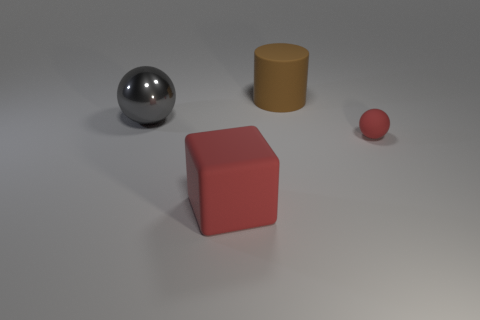Is there any other thing that is the same shape as the large brown object?
Offer a very short reply. No. What color is the matte object that is the same shape as the large gray shiny thing?
Ensure brevity in your answer.  Red. Is the shape of the tiny rubber object the same as the gray thing?
Provide a succinct answer. Yes. How many cylinders are red things or gray metallic objects?
Your answer should be very brief. 0. There is a large thing that is made of the same material as the big red cube; what is its color?
Your answer should be compact. Brown. Does the object that is in front of the rubber ball have the same size as the big gray object?
Your answer should be very brief. Yes. Do the large ball and the big object that is in front of the large gray sphere have the same material?
Offer a terse response. No. There is a rubber thing that is on the left side of the large brown rubber thing; what is its color?
Give a very brief answer. Red. There is a thing that is to the right of the brown rubber cylinder; is there a object that is to the right of it?
Offer a terse response. No. There is a large thing that is in front of the shiny sphere; is its color the same as the sphere that is in front of the big ball?
Provide a short and direct response. Yes. 